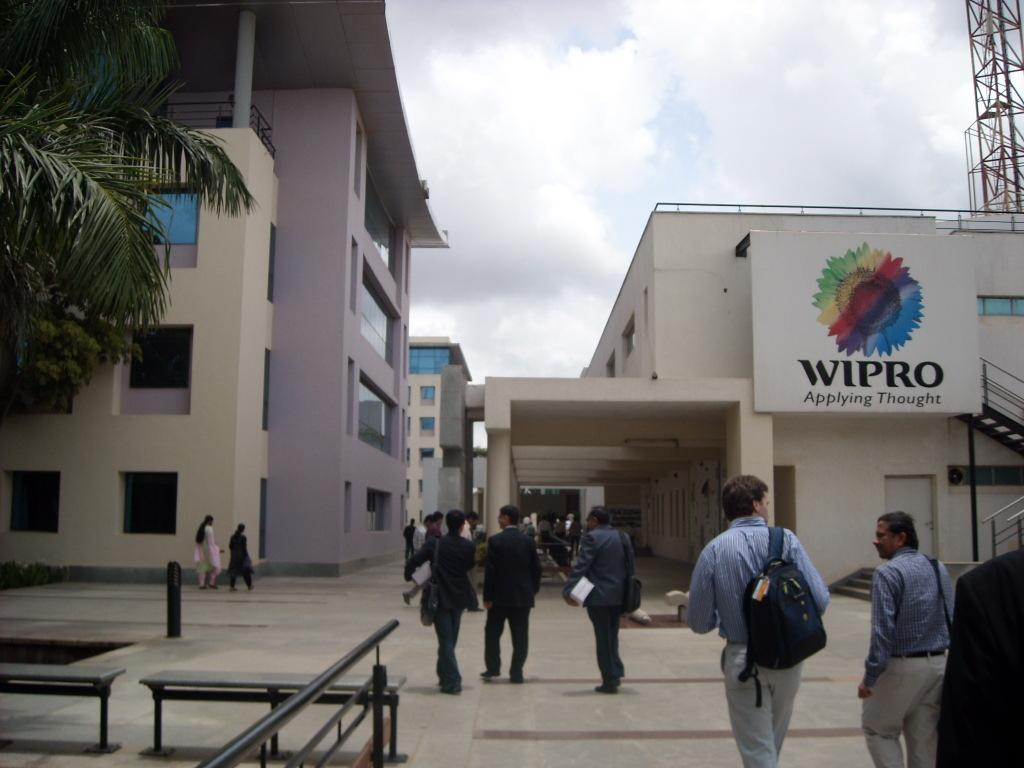What type of seating is visible in the image? There are benches in the image. What material are the iron rods made of? The iron rods are made of iron. Can you describe the people in the image? There is a group of people standing in the image. What type of structures can be seen in the image? There are buildings and a tower in the image. What type of vegetation is present in the image? There are trees in the image. What is the purpose of the board in the image? The purpose of the board is not specified in the image. What is visible in the background of the image? The sky is visible in the background of the image. How many pins are holding the holiday decorations in the image? There are no holiday decorations or pins present in the image. What type of self-portrait can be seen in the image? There is no self-portrait present in the image. 